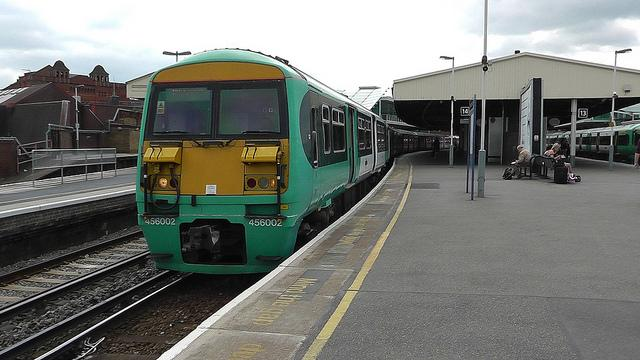What are the people on the bench doing? Please explain your reasoning. waiting. The people on the bench want to get on the next train. 